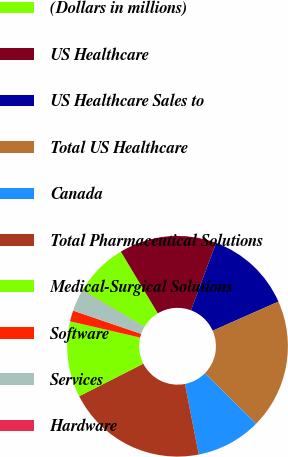Convert chart. <chart><loc_0><loc_0><loc_500><loc_500><pie_chart><fcel>(Dollars in millions)<fcel>US Healthcare<fcel>US Healthcare Sales to<fcel>Total US Healthcare<fcel>Canada<fcel>Total Pharmaceutical Solutions<fcel>Medical-Surgical Solutions<fcel>Software<fcel>Services<fcel>Hardware<nl><fcel>7.94%<fcel>14.27%<fcel>12.69%<fcel>19.02%<fcel>9.53%<fcel>20.6%<fcel>11.11%<fcel>1.61%<fcel>3.2%<fcel>0.03%<nl></chart> 